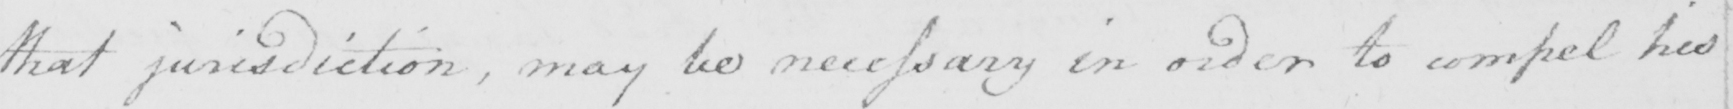Please transcribe the handwritten text in this image. that jurisdiction , may be necessary in order to compel his 